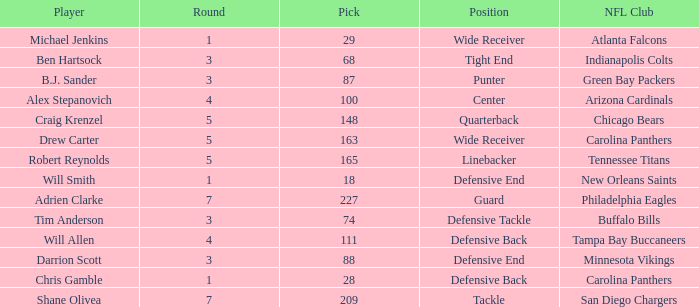What is the average Round number of Player Adrien Clarke? 7.0. 